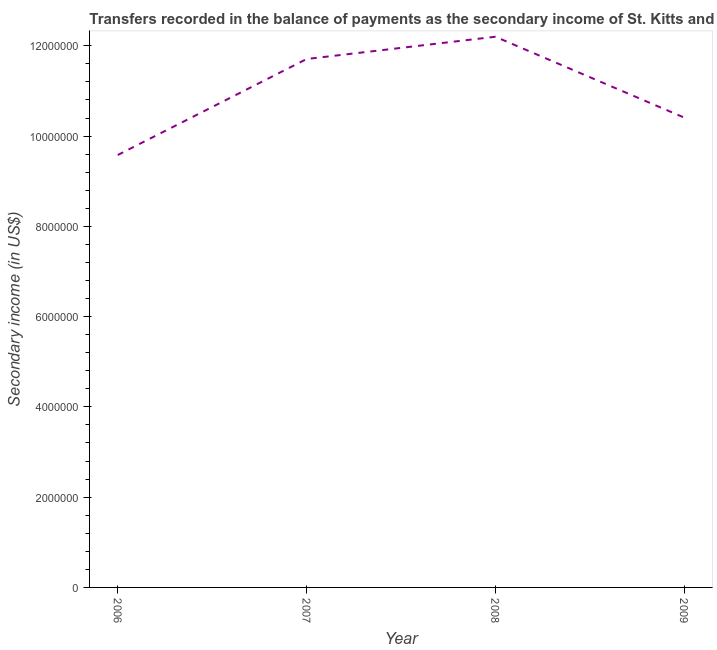What is the amount of secondary income in 2007?
Your answer should be compact. 1.17e+07. Across all years, what is the maximum amount of secondary income?
Offer a terse response. 1.22e+07. Across all years, what is the minimum amount of secondary income?
Keep it short and to the point. 9.58e+06. In which year was the amount of secondary income minimum?
Keep it short and to the point. 2006. What is the sum of the amount of secondary income?
Offer a very short reply. 4.39e+07. What is the difference between the amount of secondary income in 2006 and 2008?
Your answer should be very brief. -2.62e+06. What is the average amount of secondary income per year?
Make the answer very short. 1.10e+07. What is the median amount of secondary income?
Provide a succinct answer. 1.11e+07. What is the ratio of the amount of secondary income in 2007 to that in 2009?
Your answer should be very brief. 1.12. What is the difference between the highest and the second highest amount of secondary income?
Provide a short and direct response. 4.94e+05. Is the sum of the amount of secondary income in 2007 and 2009 greater than the maximum amount of secondary income across all years?
Ensure brevity in your answer.  Yes. What is the difference between the highest and the lowest amount of secondary income?
Provide a succinct answer. 2.62e+06. In how many years, is the amount of secondary income greater than the average amount of secondary income taken over all years?
Offer a terse response. 2. How many lines are there?
Offer a very short reply. 1. How many years are there in the graph?
Make the answer very short. 4. What is the title of the graph?
Make the answer very short. Transfers recorded in the balance of payments as the secondary income of St. Kitts and Nevis. What is the label or title of the Y-axis?
Offer a very short reply. Secondary income (in US$). What is the Secondary income (in US$) in 2006?
Make the answer very short. 9.58e+06. What is the Secondary income (in US$) of 2007?
Your answer should be compact. 1.17e+07. What is the Secondary income (in US$) in 2008?
Your response must be concise. 1.22e+07. What is the Secondary income (in US$) of 2009?
Keep it short and to the point. 1.04e+07. What is the difference between the Secondary income (in US$) in 2006 and 2007?
Provide a short and direct response. -2.13e+06. What is the difference between the Secondary income (in US$) in 2006 and 2008?
Offer a terse response. -2.62e+06. What is the difference between the Secondary income (in US$) in 2006 and 2009?
Offer a terse response. -8.29e+05. What is the difference between the Secondary income (in US$) in 2007 and 2008?
Provide a succinct answer. -4.94e+05. What is the difference between the Secondary income (in US$) in 2007 and 2009?
Your response must be concise. 1.30e+06. What is the difference between the Secondary income (in US$) in 2008 and 2009?
Offer a terse response. 1.79e+06. What is the ratio of the Secondary income (in US$) in 2006 to that in 2007?
Offer a very short reply. 0.82. What is the ratio of the Secondary income (in US$) in 2006 to that in 2008?
Offer a very short reply. 0.79. What is the ratio of the Secondary income (in US$) in 2006 to that in 2009?
Offer a very short reply. 0.92. What is the ratio of the Secondary income (in US$) in 2008 to that in 2009?
Offer a terse response. 1.17. 